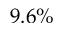<formula> <loc_0><loc_0><loc_500><loc_500>9 . 6 \%</formula> 